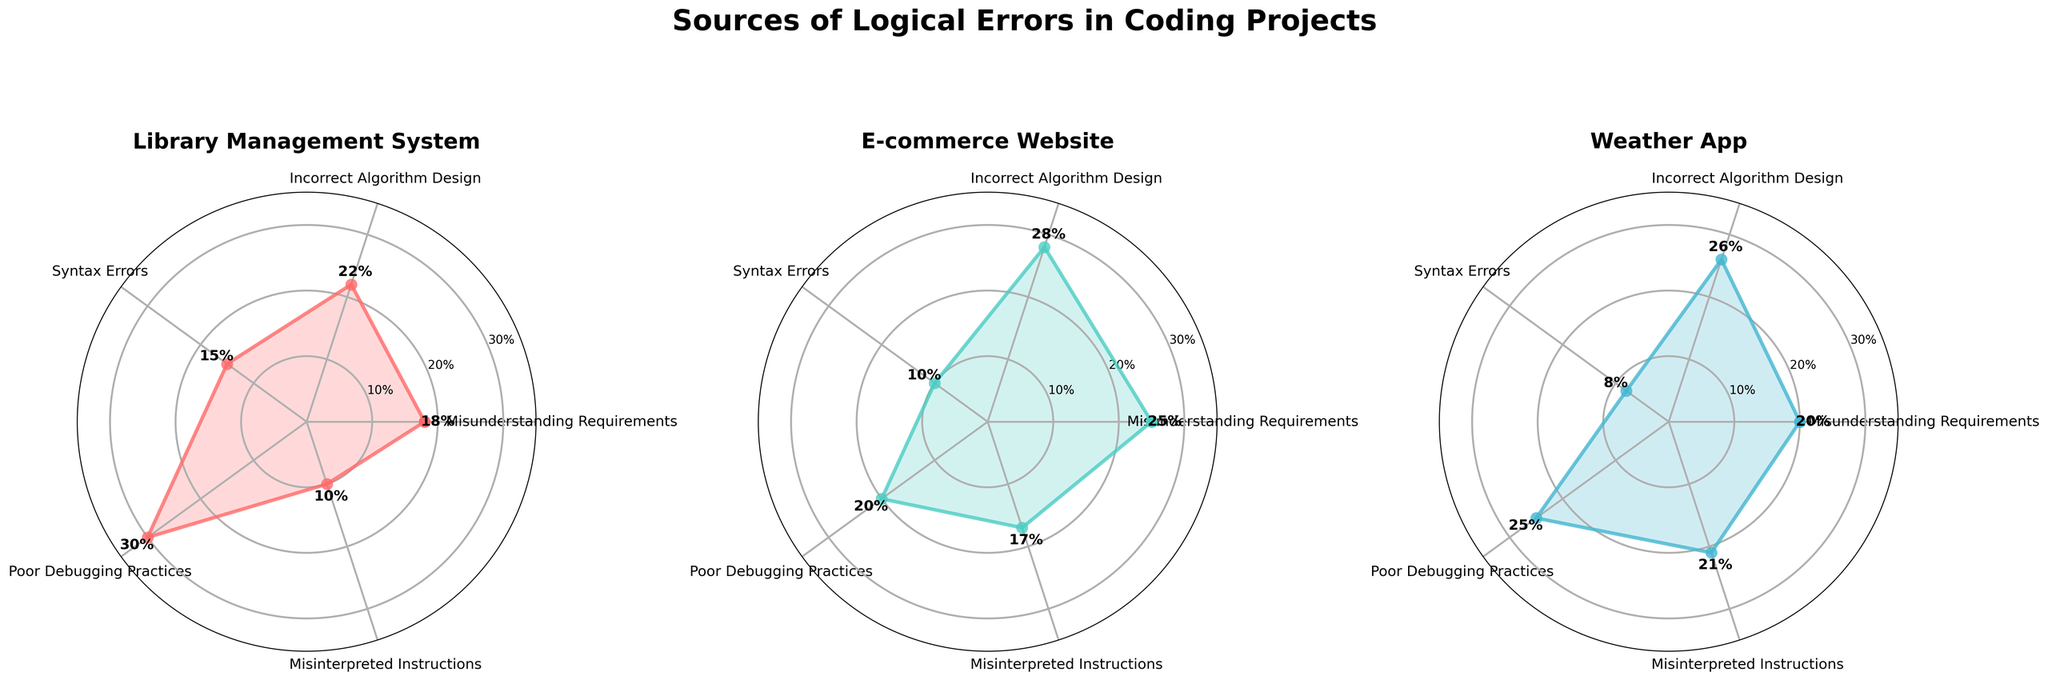what are the categories displayed in the radar charts? The radar charts plot data for the following categories: Misunderstanding Requirements, Incorrect Algorithm Design, Syntax Errors, Poor Debugging Practices, and Misinterpreted Instructions.
Answer: Misunderstanding Requirements, Incorrect Algorithm Design, Syntax Errors, Poor Debugging Practices, Misinterpreted Instructions what are the highest percentages of errors in the Library Management System project? Looking at the Library Management System radar chart, the highest percentage of errors is shown for Poor Debugging Practices, followed by Incorrect Algorithm Design and Misunderstanding Requirements.
Answer: Poor Debugging Practices which project has the least syntax errors? By comparing the charts, the E-commerce Website shows the least occurrence of Syntax Errors at 10%, preceded by Weather App at 8%.
Answer: Weather App what's the average percentage of Misunderstanding Requirements reported across all projects? Sum the percentages for Misunderstanding Requirements from all projects (18 + 25 + 20), then divide by the number of projects (3).
Answer: (18 + 25 + 20)/3 = 21 which category shows the highest percentage in the E-commerce Website project? The radar chart for E-commerce Website displays the highest percentage for Incorrect Algorithm Design at 28%.
Answer: Incorrect Algorithm Design comparing Poor Debugging Practices, which project has the second-highest percentage? The radar chart indicates that the second-highest percentage for Poor Debugging Practices is observed in the Weather App at 25%.
Answer: Weather App what is the percentage difference of Misinterpreted Instructions between the Library Management System and Weather App? Subtract the percentage of Misinterpreted Instructions in the Library Management System (10%) from that in the Weather App (21%).
Answer: 21 - 10 = 11 which category shows a drastic difference in percentage between E-commerce Website and Weather App? Incorrect Algorithm Design shows a 2% difference (28% for E-commerce Website and 26% for Weather App). Misinterpreted Instructions demonstrate significant differences, with 17% for E-commerce Website and 21% for Weather App.
Answer: Misinterpreted Instructions what is the collective percentage for Incorrect Algorithm Design across all projects? Sum up the percentages for Incorrect Algorithm Design across all three projects: (22 + 28 + 26).
Answer: 22 + 28 + 26 = 76 what can be inferred if Poor Debugging Practices are high in a project? A high percentage implies that a significant portion of logical errors in coding projects arises due to inadequate debugging efforts, potentially leading to unresolved issues.
Answer: Poor Debugging Practices indicate frequent unresolved issues 